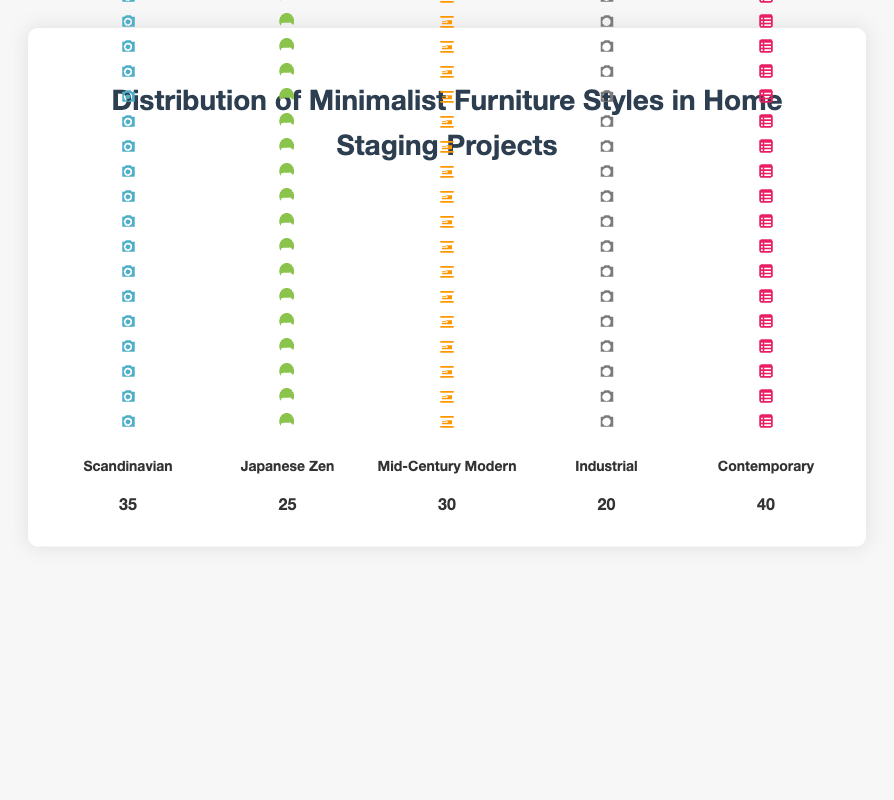What is the most popular minimalist furniture style used in home staging projects? The "Contemporary" style has the highest count label of 40, indicating it is the most popular minimalist furniture style in the data.
Answer: Contemporary How many more times is the Contemporary style used compared to the Industrial style? The Contemporary style is used 40 times and the Industrial style is used 20 times. 40 - 20 = 20, so the Contemporary style is used 20 more times.
Answer: 20 Which minimalist furniture styles have a count label of less than 30? The "Japanese Zen" and "Industrial" styles have count labels of 25 and 20, respectively, both of which are less than 30.
Answer: Japanese Zen, Industrial What is the total count of all minimalist furniture styles combined in home staging projects? Sum the count labels for all styles: 35 (Scandinavian) + 25 (Japanese Zen) + 30 (Mid-Century Modern) + 20 (Industrial) + 40 (Contemporary) = 150.
Answer: 150 Which styles have a higher count label than Japanese Zen? The "Scandinavian" (35), "Mid-Century Modern" (30), and "Contemporary" (40) styles have higher counts than the "Japanese Zen" style (25).
Answer: Scandinavian, Mid-Century Modern, Contemporary What percentage of the total is the count for Mid-Century Modern? The Mid-Century Modern style count is 30. The total count of all styles is 150. (30 / 150) * 100 = 20%, so it represents 20% of the total.
Answer: 20% Which styles have their count labels depicted with the fewest and most icons, respectively? The "Industrial" style has the fewest icons with a count of 20, and the "Contemporary" style has the most icons with a count of 40.
Answer: Industrial, Contemporary What is the average count of all the minimalist furniture styles? Sum the total counts: 150. Divide by the number of styles: 150 / 5 = 30. The average count is 30.
Answer: 30 How does the count of Scandinavian style compare to the total count of Japanese Zen and Industrial styles combined? The Scandinavian style count is 35. The combined count of Japanese Zen and Industrial styles is 25 + 20 = 45, so the combined count is 10 more than the Scandinavian style.
Answer: 10 What's the sum of the counts for Scandinavian and Mid-Century Modern styles? Sum the counts for Scandinavian and Mid-Century Modern: 35 + 30 = 65.
Answer: 65 